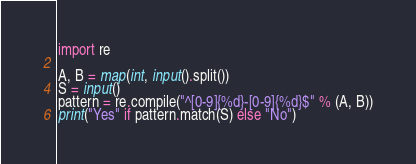Convert code to text. <code><loc_0><loc_0><loc_500><loc_500><_Python_>import re

A, B = map(int, input().split())
S = input()
pattern = re.compile("^[0-9]{%d}-[0-9]{%d}$" % (A, B))
print("Yes" if pattern.match(S) else "No")
</code> 